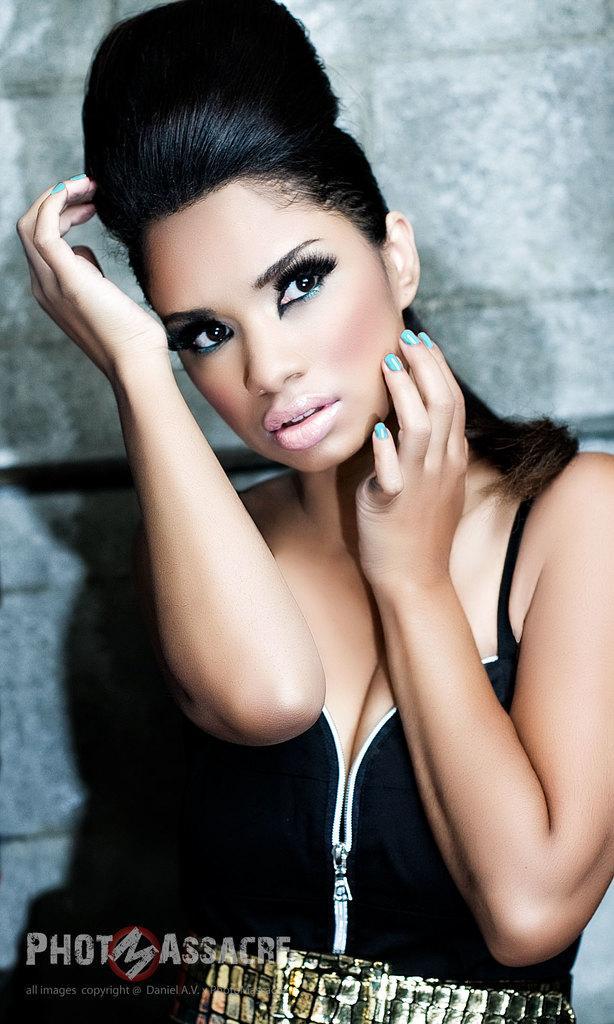In one or two sentences, can you explain what this image depicts? In this picture I can see a woman standing and I can see text at the bottom left corner of the picture and a wall on the back. 